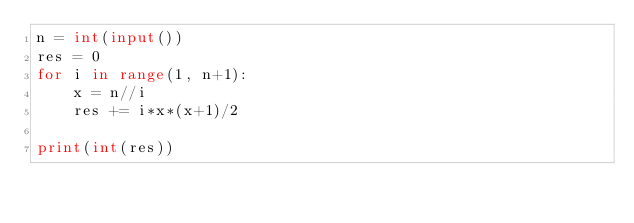<code> <loc_0><loc_0><loc_500><loc_500><_Python_>n = int(input())
res = 0
for i in range(1, n+1):
    x = n//i
    res += i*x*(x+1)/2

print(int(res))</code> 